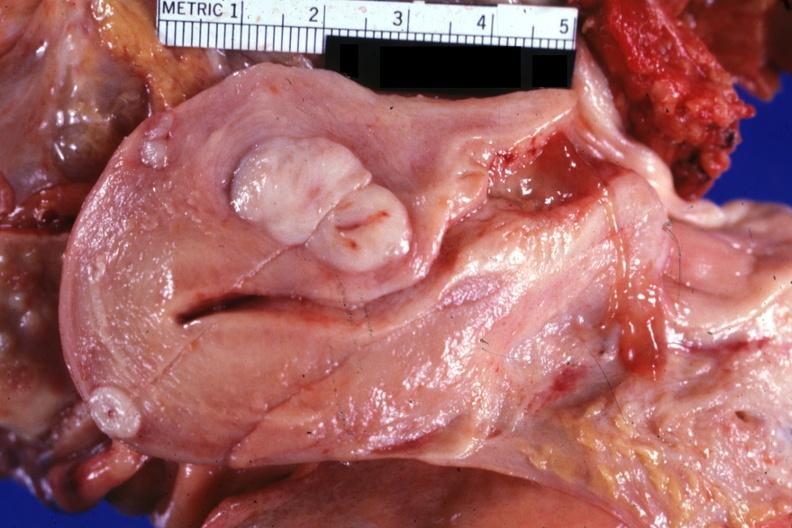how many myomas does this image show opened uterus with quite typical?
Answer the question using a single word or phrase. Three 